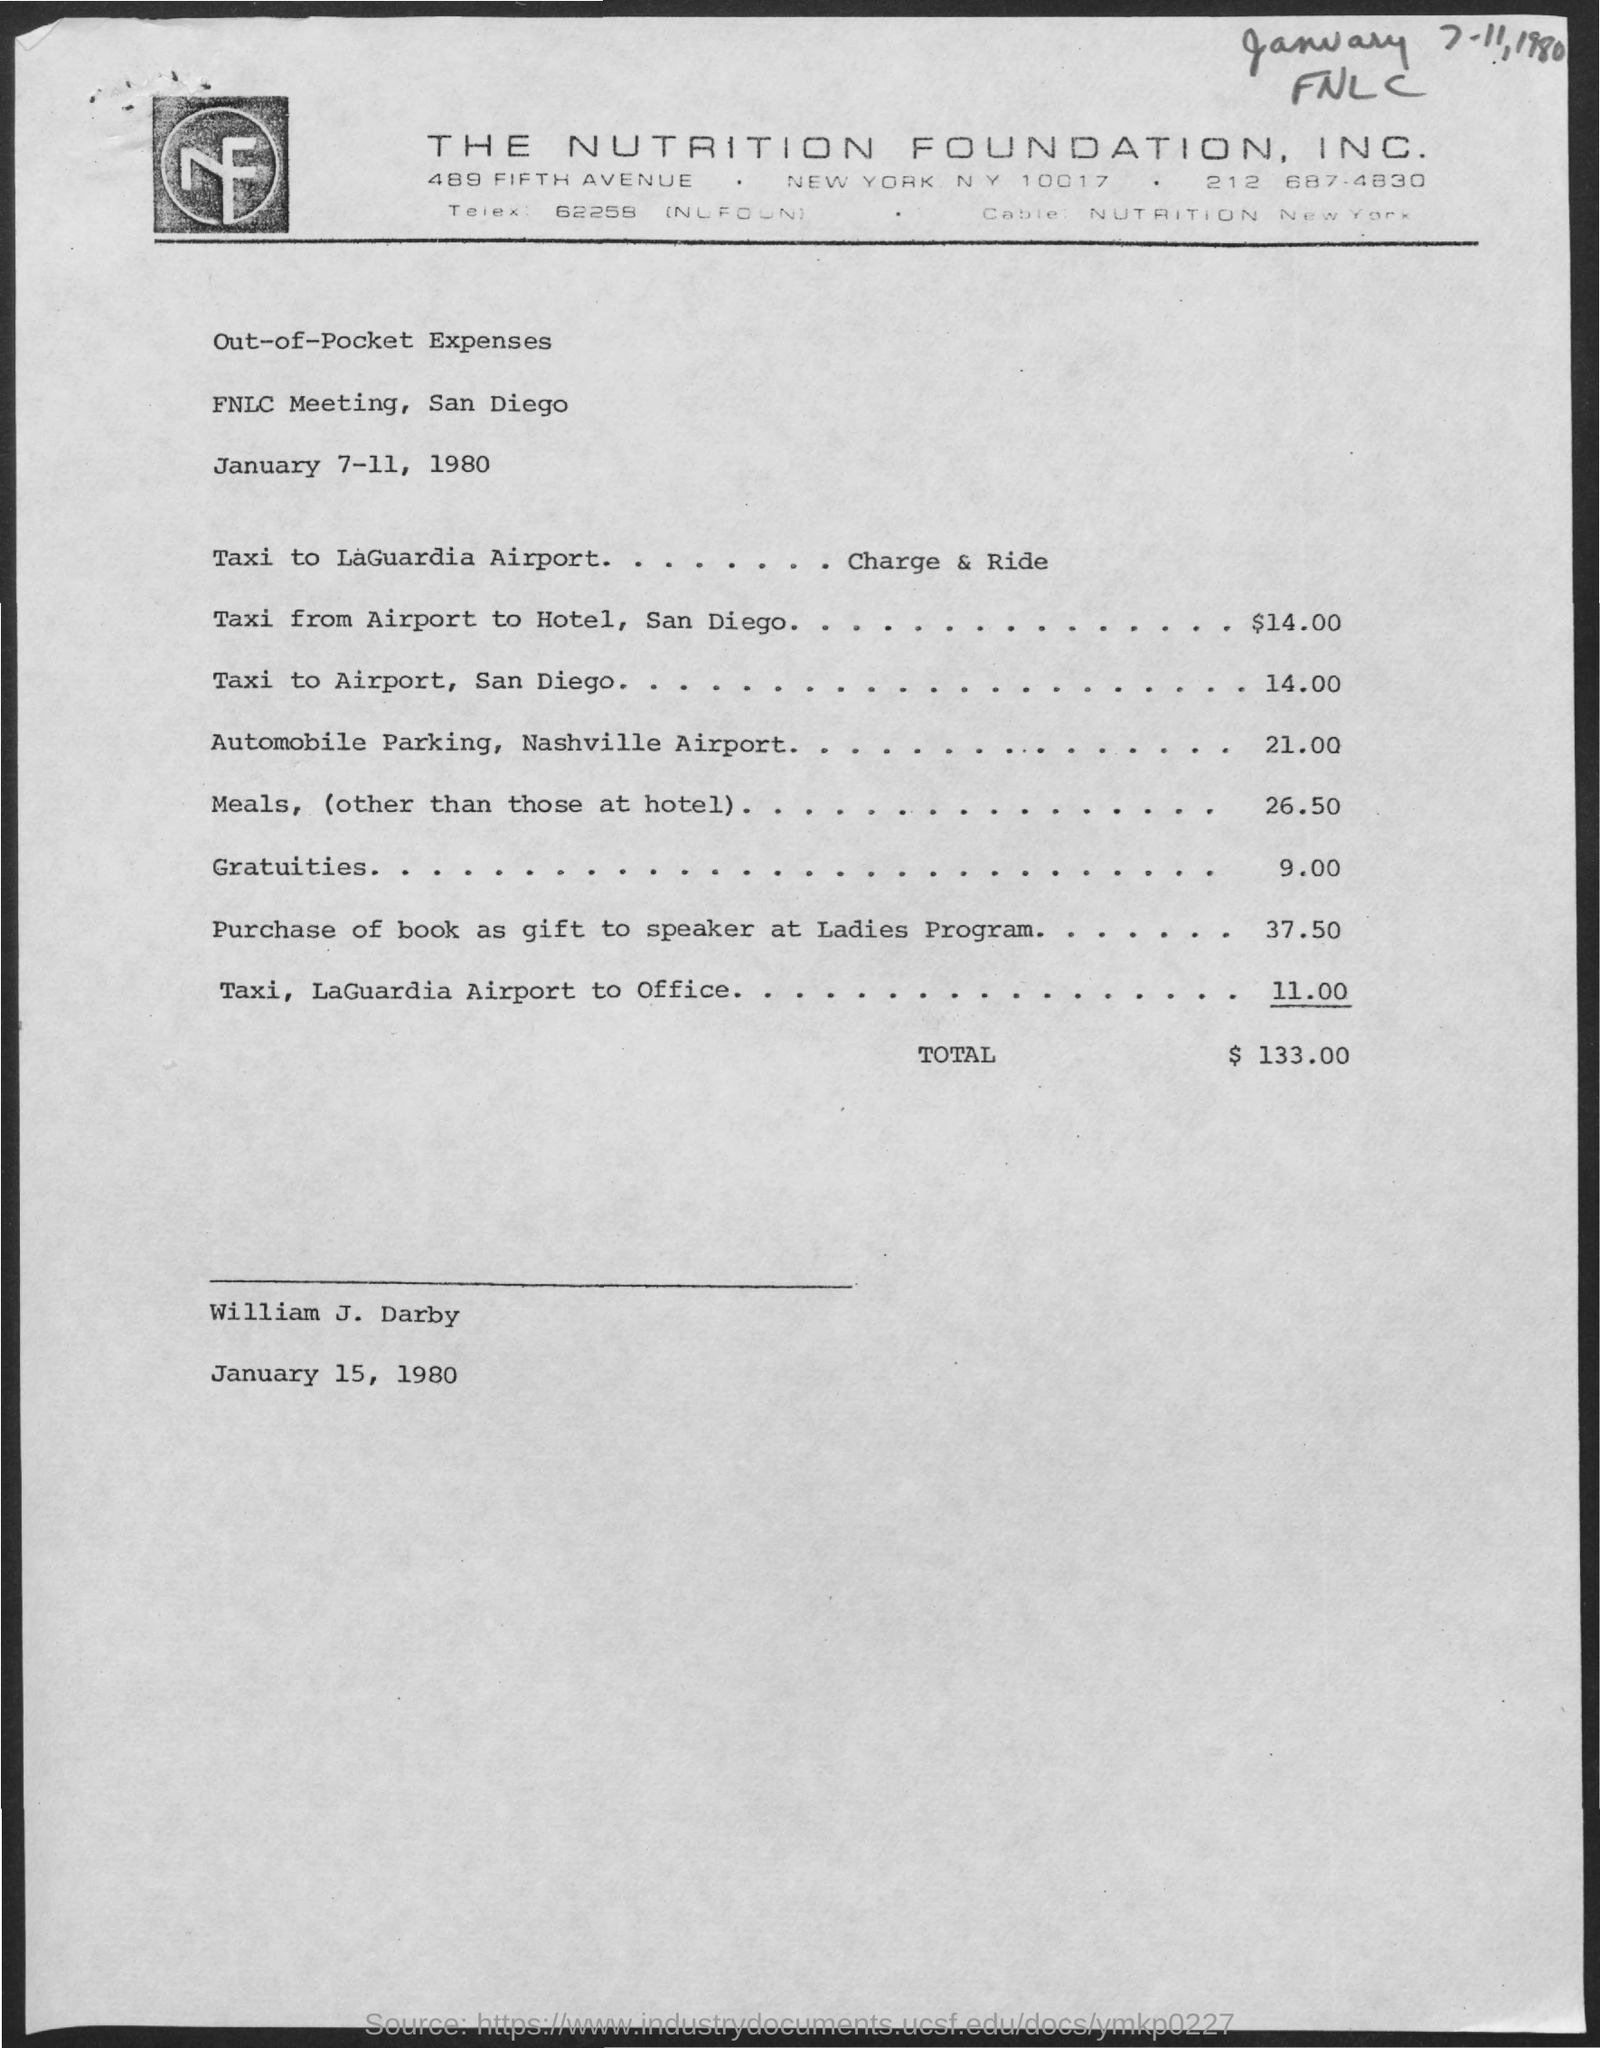Specify some key components in this picture. The dates on which the FNLC meeting is scheduled are January 7-11, 1980. You incurred expenses of approximately 26.50 for meals other than those at the hotel. The cost for automobile parking at the Nashville airport is $21.00. The estimated cost of a taxi ride from the San Diego airport to a hotel is $14.00. 